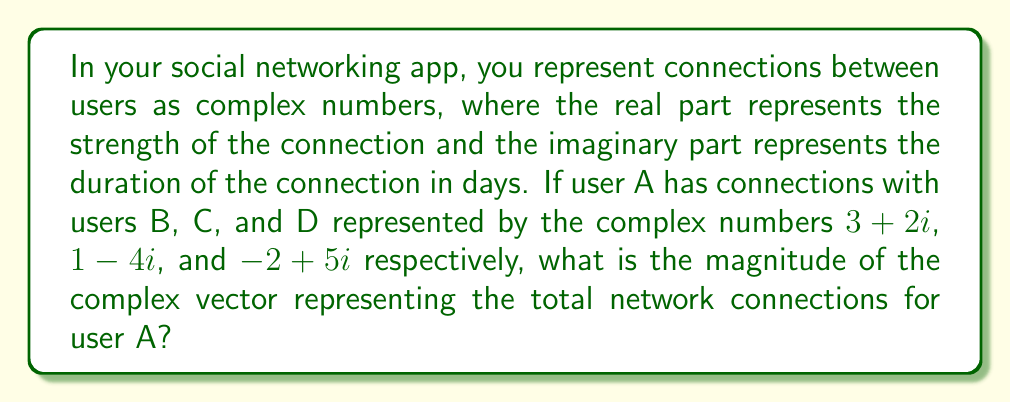Show me your answer to this math problem. To solve this problem, we need to follow these steps:

1) First, we need to add all the complex numbers representing the connections:
   $$(3+2i) + (1-4i) + (-2+5i) = 2+3i$$

2) Now we have a single complex number $2+3i$ representing the total network connections for user A.

3) To find the magnitude of this complex number, we use the formula:
   $$|a+bi| = \sqrt{a^2 + b^2}$$
   where $a$ is the real part and $b$ is the imaginary part.

4) Substituting our values:
   $$|2+3i| = \sqrt{2^2 + 3^2}$$

5) Simplify:
   $$|2+3i| = \sqrt{4 + 9} = \sqrt{13}$$

Therefore, the magnitude of the complex vector representing the total network connections for user A is $\sqrt{13}$.
Answer: $\sqrt{13}$ 